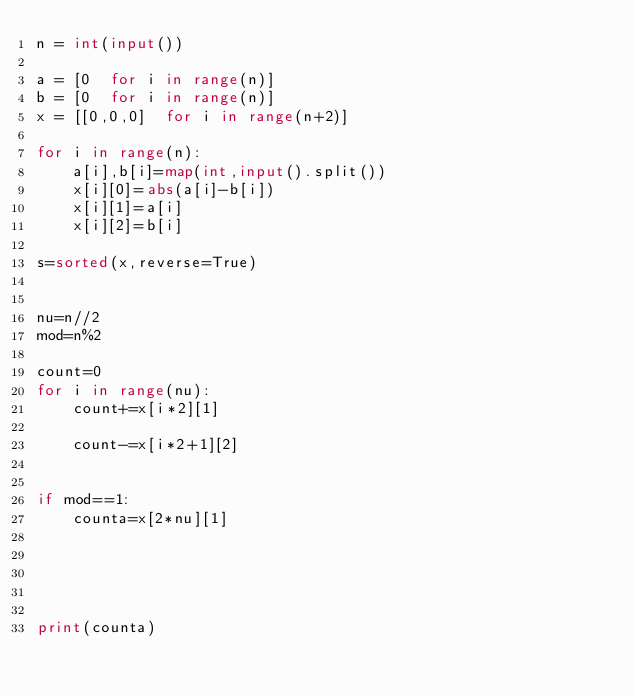<code> <loc_0><loc_0><loc_500><loc_500><_Python_>n = int(input())

a = [0  for i in range(n)]
b = [0  for i in range(n)]
x = [[0,0,0]  for i in range(n+2)]

for i in range(n):
    a[i],b[i]=map(int,input().split())
    x[i][0]=abs(a[i]-b[i])
    x[i][1]=a[i]
    x[i][2]=b[i]

s=sorted(x,reverse=True)


nu=n//2
mod=n%2

count=0
for i in range(nu):
    count+=x[i*2][1]

    count-=x[i*2+1][2]


if mod==1:
    counta=x[2*nu][1]

    

    

print(counta)</code> 